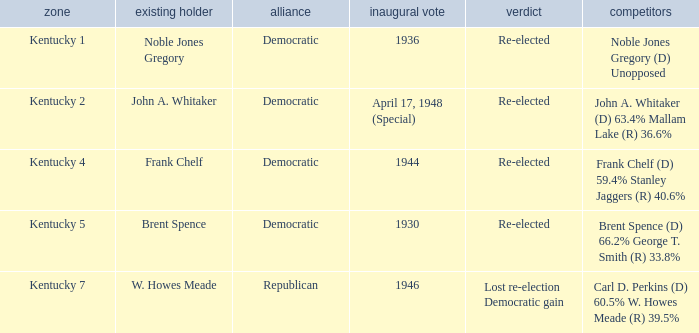Who were the candidates in the Kentucky 4 voting district? Frank Chelf (D) 59.4% Stanley Jaggers (R) 40.6%. 